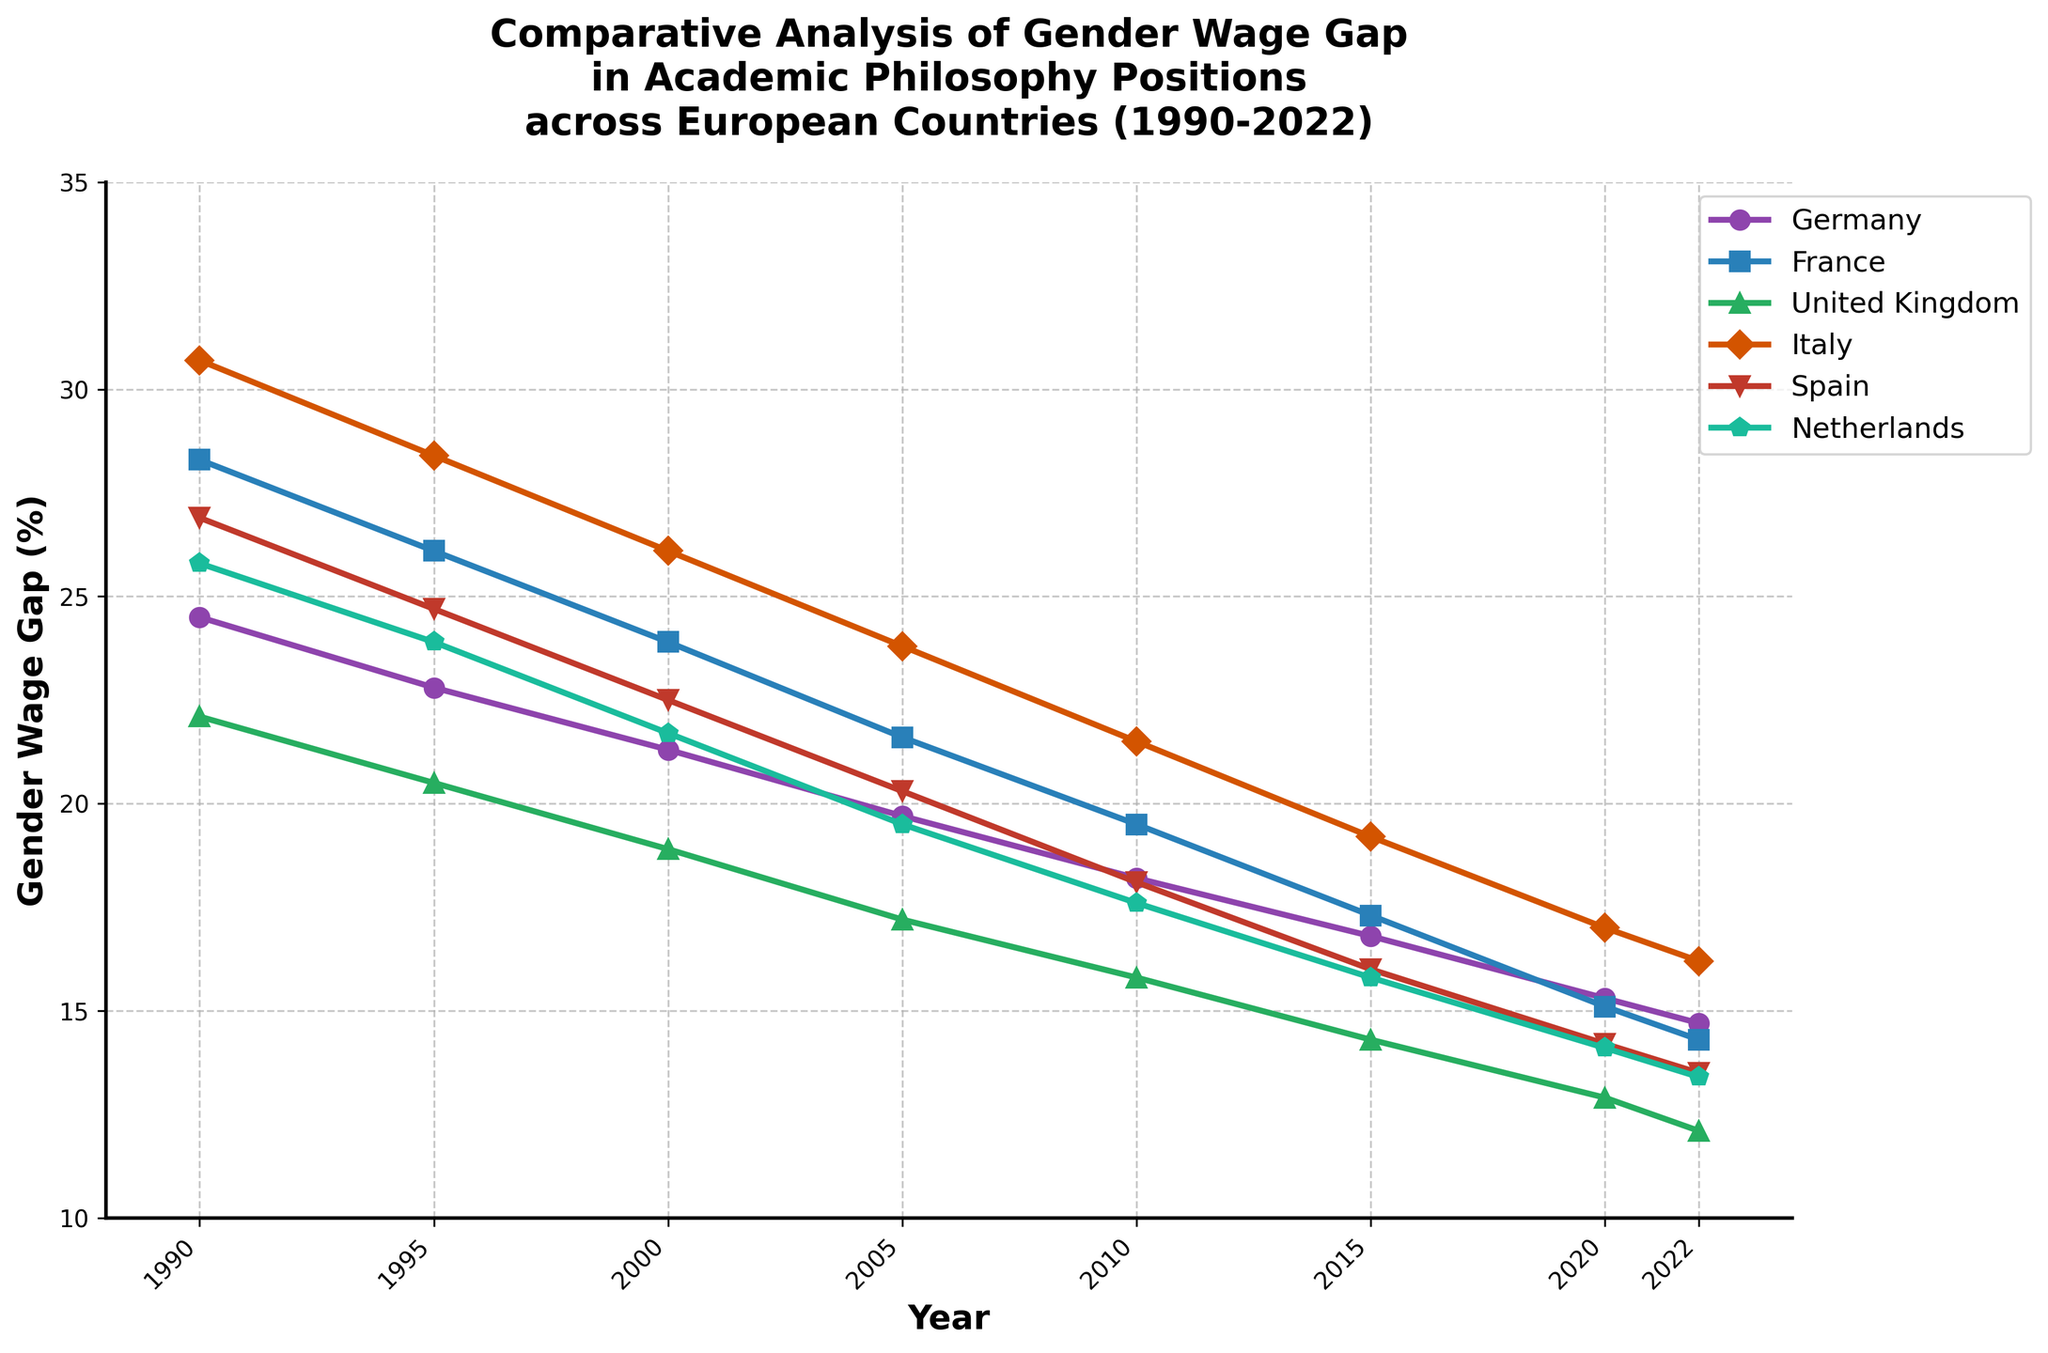What is the trend in the gender wage gap in academic philosophy positions in Germany from 1990 to 2022? To identify the trend, observe the line corresponding to Germany. Notice that the values decrease consistently from 24.5% in 1990 to 14.7% in 2022, indicating a downward trend.
Answer: The trend is downward Which country had the lowest gender wage gap in 2022, and what was the percentage? By looking at the chart for the year 2022, observe the data points for each country. The United Kingdom has the lowest gender wage gap in 2022 with a value of 12.1%.
Answer: United Kingdom, 12.1% In which years did Spain experience a greater gender wage gap than Italy? Refer to the plotted lines for Spain and Italy. Spain had a greater gender wage gap than Italy in 1990 and 1995.
Answer: 1990, 1995 What is the average gender wage gap in the Netherlands from 1990 through 2022? Calculate the arithmetic mean of the percentage values for the Netherlands from 1990 to 2022: (25.8 + 23.9 + 21.7 + 19.5 + 17.6 + 15.8 + 14.1 + 13.4) / 8 = 18.5%
Answer: 18.5% Between 1990 and 2022, in which country did the gender wage gap decrease the most, and by how many percentage points? To find this, compute the difference in the gender wage gap from 1990 to 2022 for each country:
Germany: 24.5 - 14.7 = 9.8
France: 28.3 - 14.3 = 14.0
UK: 22.1 - 12.1 = 10.0
Italy: 30.7 - 16.2 = 14.5
Spain: 26.9 - 13.5 = 13.4
Netherlands: 25.8 - 13.4 = 12.4
Italy experienced the largest decrease of 14.5 percentage points.
Answer: Italy, 14.5 percentage points Which two countries' gender wage gaps were closest in 2005, and what were their values? Look at the data points for each country in 2005. Germany and Netherlands had very close values: Germany at 19.7% and Netherlands at 19.5%, differing by only 0.2 percentage points.
Answer: Germany (19.7%), Netherlands (19.5%) In 2010, how did the gender wage gap in France compare to that in Italy? Look at the points for France and Italy in 2010: France had a 19.5% gap, whereas Italy had a 21.5% gap. France's gender wage gap was lower than Italy's by 2.0 percentage points.
Answer: France was lower by 2.0 percentage points What year did the United Kingdom reach a gender wage gap of approximately 15% or less? Look at the line for the United Kingdom and spot the year when the value first dropped to around or below 15%. This occurred in 2015 when the wage gap reached 14.3%.
Answer: 2015 Which country has shown the most consistent reduction in the gender wage gap from 1990 to 2022? Observe each country's line for consistency in reduction. Germany shows a steady and consistent drop in values across the entire period.
Answer: Germany 